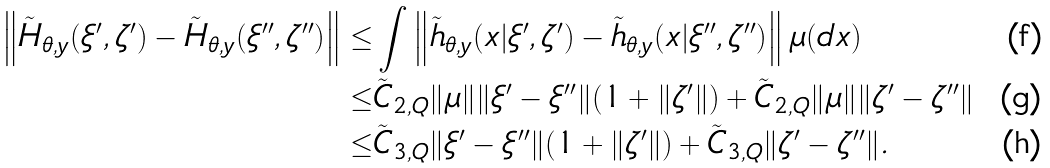Convert formula to latex. <formula><loc_0><loc_0><loc_500><loc_500>\left \| \tilde { H } _ { \theta , y } ( \xi ^ { \prime } , \zeta ^ { \prime } ) - \tilde { H } _ { \theta , y } ( \xi ^ { \prime \prime } , \zeta ^ { \prime \prime } ) \right \| \leq & \int \left \| \tilde { h } _ { \theta , y } ( x | \xi ^ { \prime } , \zeta ^ { \prime } ) - \tilde { h } _ { \theta , y } ( x | \xi ^ { \prime \prime } , \zeta ^ { \prime \prime } ) \right \| \mu ( d x ) \\ \leq & \tilde { C } _ { 2 , Q } \| \mu \| \| \xi ^ { \prime } - \xi ^ { \prime \prime } \| ( 1 + \| \zeta ^ { \prime } \| ) + \tilde { C } _ { 2 , Q } \| \mu \| \| \zeta ^ { \prime } - \zeta ^ { \prime \prime } \| \\ \leq & \tilde { C } _ { 3 , Q } \| \xi ^ { \prime } - \xi ^ { \prime \prime } \| ( 1 + \| \zeta ^ { \prime } \| ) + \tilde { C } _ { 3 , Q } \| \zeta ^ { \prime } - \zeta ^ { \prime \prime } \| .</formula> 